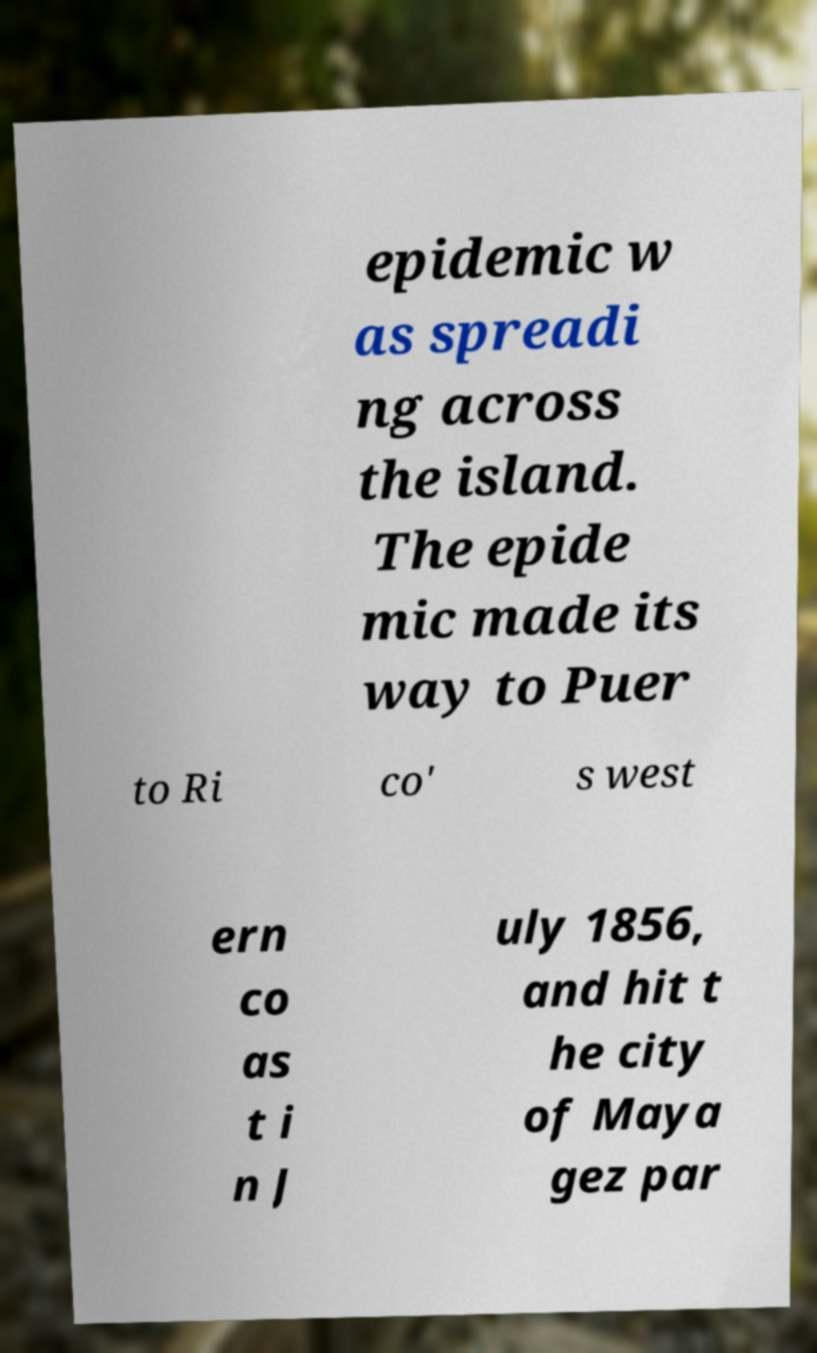For documentation purposes, I need the text within this image transcribed. Could you provide that? epidemic w as spreadi ng across the island. The epide mic made its way to Puer to Ri co' s west ern co as t i n J uly 1856, and hit t he city of Maya gez par 